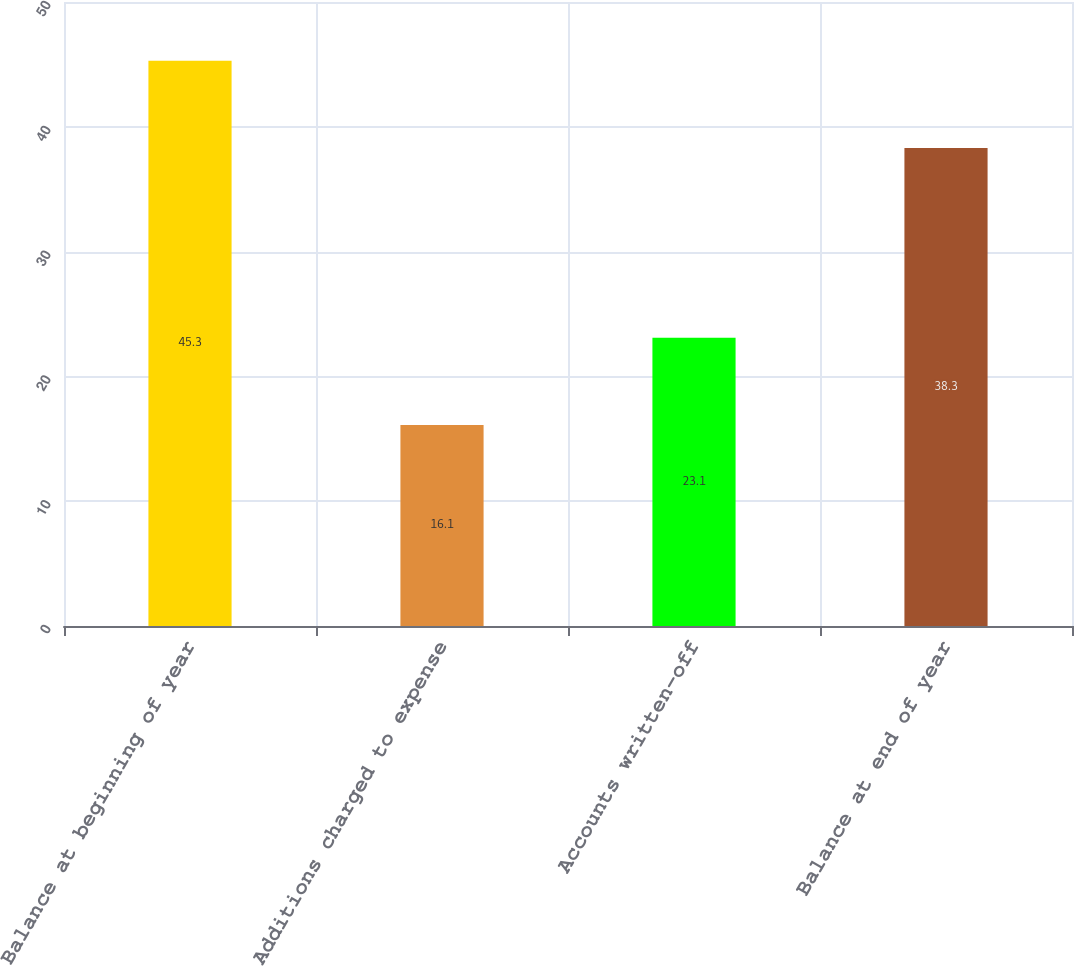Convert chart. <chart><loc_0><loc_0><loc_500><loc_500><bar_chart><fcel>Balance at beginning of year<fcel>Additions charged to expense<fcel>Accounts written-off<fcel>Balance at end of year<nl><fcel>45.3<fcel>16.1<fcel>23.1<fcel>38.3<nl></chart> 